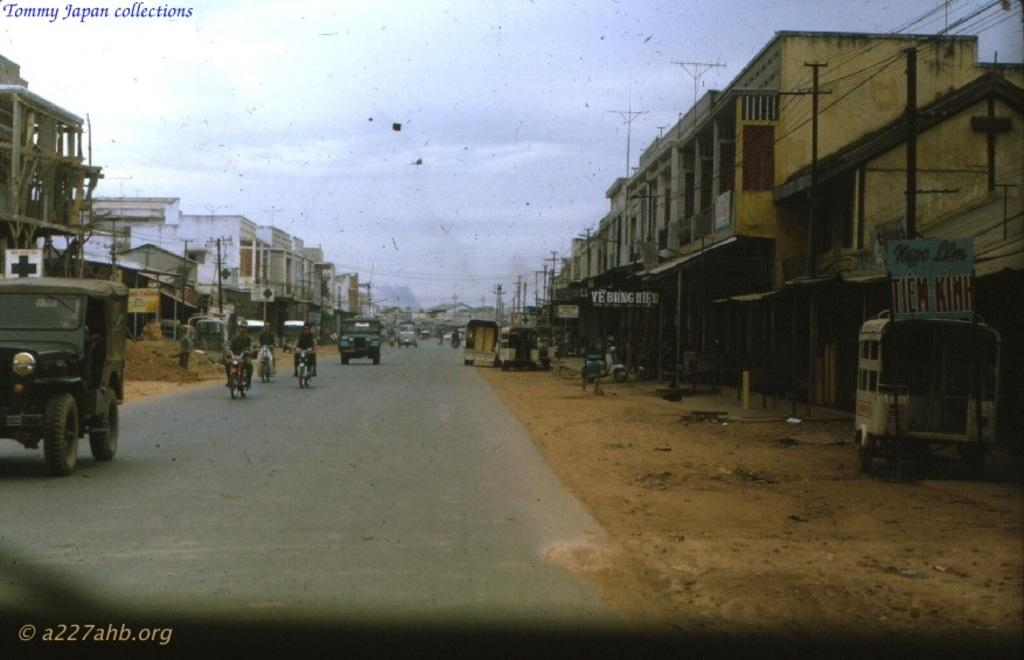What types of transportation can be seen in the image? There are vehicles in the image. What activity are some people engaged in? There are people riding bikes in the image. What structures are visible in the image? There are buildings in the image. What decorative elements can be seen in the image? There are banners in the image. What objects are present in the image that might be used for support or signage? There are poles in the image. What can be seen in the background of the image? The sky is visible in the background of the image, and there are clouds in the sky. Can you tell me how many shoes are being exchanged in the image? There is no exchange of shoes depicted in the image. What type of cough is being suppressed by the person riding a bike in the image? There is no person riding a bike suppressing a cough in the image. 